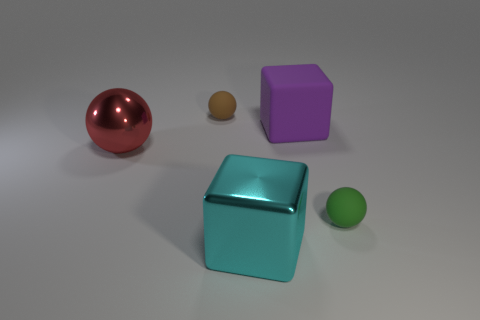How many objects are either tiny rubber objects behind the large red shiny ball or blocks that are in front of the green object?
Make the answer very short. 2. There is a big object that is the same shape as the small brown object; what material is it?
Ensure brevity in your answer.  Metal. How many rubber objects are either big red objects or brown objects?
Provide a succinct answer. 1. What shape is the cyan object that is the same material as the red ball?
Provide a short and direct response. Cube. What number of other tiny green things have the same shape as the green matte object?
Ensure brevity in your answer.  0. Is the shape of the tiny rubber object that is to the right of the brown sphere the same as the small matte object that is behind the green ball?
Make the answer very short. Yes. What number of things are tiny brown cubes or rubber balls left of the cyan shiny cube?
Ensure brevity in your answer.  1. How many cyan things are the same size as the red shiny ball?
Your answer should be compact. 1. How many brown things are large cylinders or rubber spheres?
Offer a very short reply. 1. There is a large shiny object that is right of the tiny rubber sphere to the left of the cyan cube; what is its shape?
Your answer should be compact. Cube. 